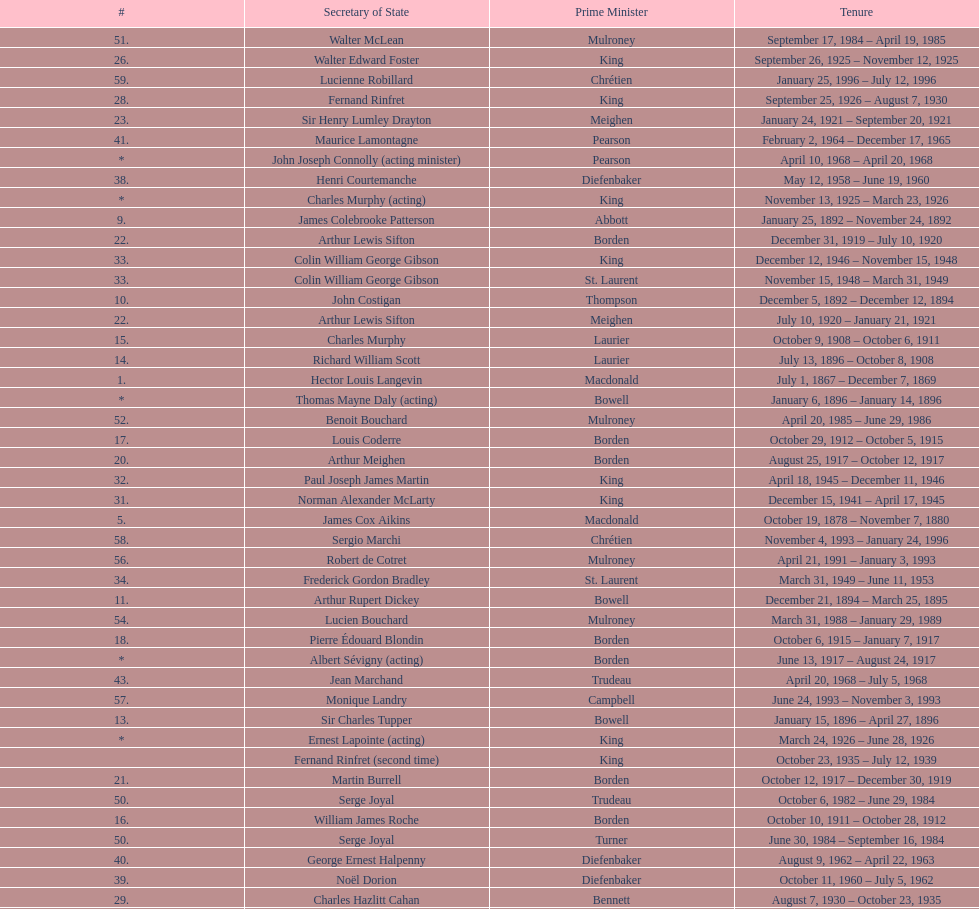What secretary of state served under both prime minister laurier and prime minister king? Charles Murphy. 